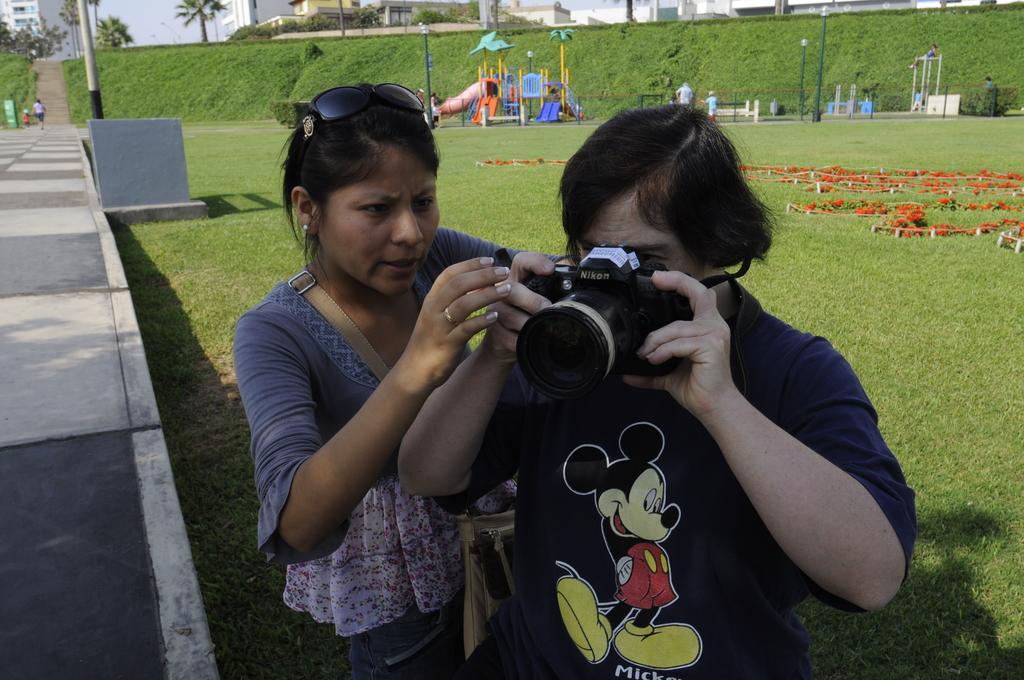In one or two sentences, can you explain what this image depicts? In the image we can see there are two person together, the right side person is holding camera in his hand and the left side one is looking at it. This is a grass, play toys, building, trees and pole. 